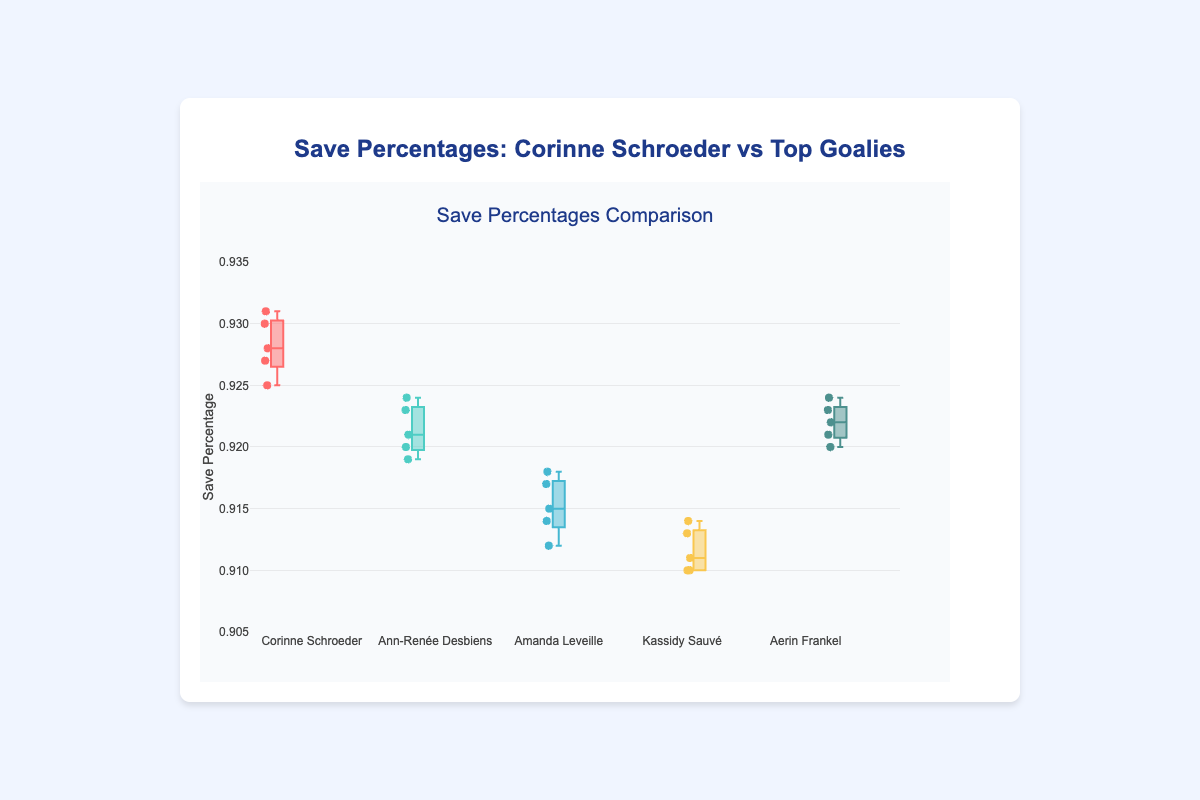What is the title of the figure? Look at the top of the figure where the main heading is displayed.
Answer: Save Percentages: Corinne Schroeder vs Top Goalies What is the range of the y-axis? Observe the axis running vertically on the left side of the plot.
Answer: 0.905 to 0.935 Which goalie has the highest median save percentage? Check each box plot's central line, which represents the median.
Answer: Corinne Schroeder How many data points are there for Ann-Renée Desbiens? Find the number of points displayed within the box plot markers for Ann-Renée Desbiens.
Answer: 5 Which goalies have overlapping interquartile ranges? Observe the central box areas of each goalie's plot to see which boxes overlap vertically.
Answer: Ann-Renée Desbiens and Aerin Frankel What is the median save percentage of Corinne Schroeder? Look at the central line in Corinne Schroeder's box plot.
Answer: 0.928 How does Amanda Leveille's interquartile range compare to Kassidy Sauvé's? Compare the width of the boxes (interquartile ranges) for Amanda Leveille and Kassidy Sauvé.
Answer: Amanda Leveille's interquartile range is larger Who has the lowest maximum save percentage? Check the top whisker of each box plot to see which goalie has the lowest top value.
Answer: Kassidy Sauvé What can be said about the consistency of Corinne Schroeder's performances compared to Kassidy Sauvé's? Analyze the sizes of the boxes and lengths of the whiskers for both goalies to compare consistency. Corinne Schroeder's box is more compact, indicating less variability.
Answer: Corinne Schroeder's performances are more consistent Which goalie has the narrowest range of save percentages? Notice the length of the entire vertical spread (whiskers) for each goalie's plot.
Answer: Aerin Frankel 